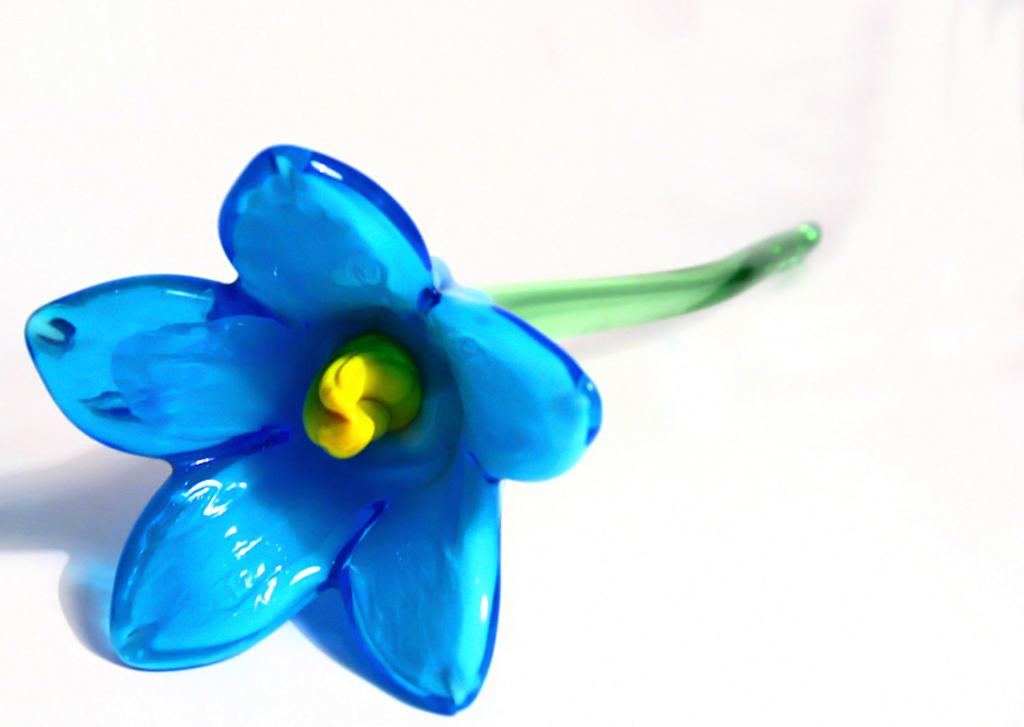What type of object is present in the image? There is an artificial flower in the image. What type of jam is spread on the back of the artificial flower in the image? There is no jam present in the image, and the artificial flower does not have a back. 